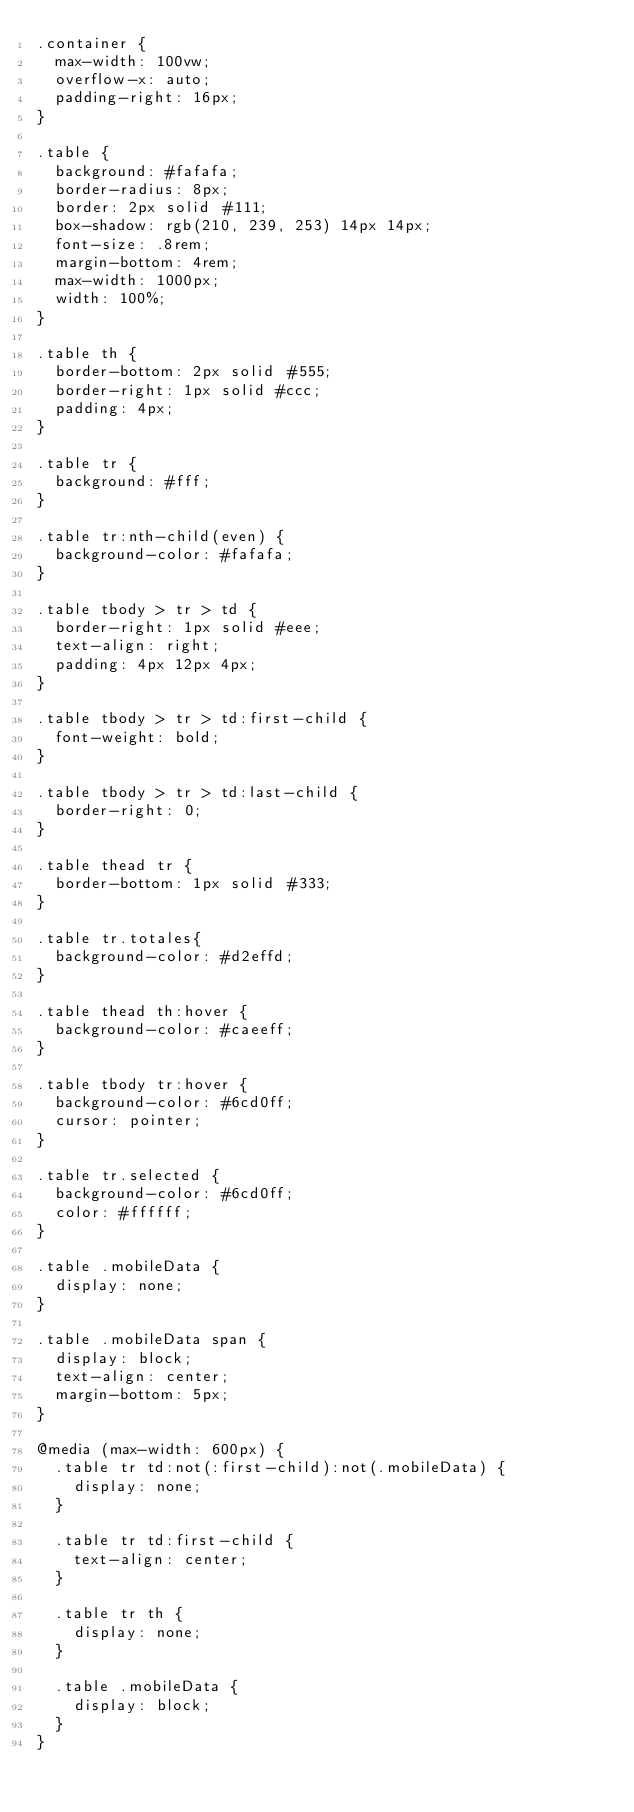<code> <loc_0><loc_0><loc_500><loc_500><_CSS_>.container {
  max-width: 100vw;
  overflow-x: auto;
  padding-right: 16px;
}

.table {
  background: #fafafa;
  border-radius: 8px;
  border: 2px solid #111;
  box-shadow: rgb(210, 239, 253) 14px 14px;
  font-size: .8rem;
  margin-bottom: 4rem;
  max-width: 1000px;
  width: 100%;
}

.table th {
  border-bottom: 2px solid #555;
  border-right: 1px solid #ccc;
  padding: 4px;
}

.table tr {
  background: #fff;
}

.table tr:nth-child(even) {
  background-color: #fafafa;
}

.table tbody > tr > td {
  border-right: 1px solid #eee;
  text-align: right;
  padding: 4px 12px 4px;
}

.table tbody > tr > td:first-child {
  font-weight: bold;
}

.table tbody > tr > td:last-child {
  border-right: 0;
}

.table thead tr {
  border-bottom: 1px solid #333;
}

.table tr.totales{
  background-color: #d2effd;
}

.table thead th:hover {
  background-color: #caeeff;
}

.table tbody tr:hover {
  background-color: #6cd0ff;
  cursor: pointer;
}

.table tr.selected {
  background-color: #6cd0ff;
  color: #ffffff;
}

.table .mobileData {
  display: none;
}

.table .mobileData span {
  display: block;
  text-align: center;
  margin-bottom: 5px;
}

@media (max-width: 600px) {
  .table tr td:not(:first-child):not(.mobileData) {
    display: none;
  }

  .table tr td:first-child {
    text-align: center;
  }
  
  .table tr th {
    display: none;
  }

  .table .mobileData {
    display: block;
  }
}</code> 